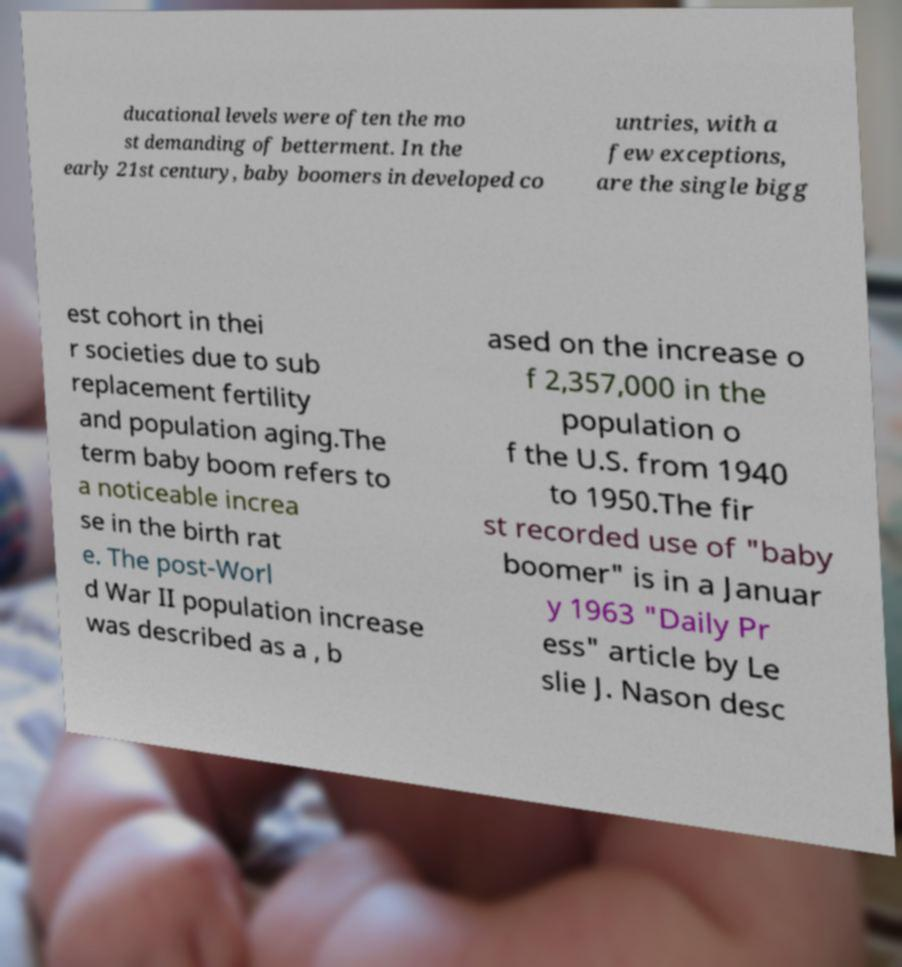For documentation purposes, I need the text within this image transcribed. Could you provide that? ducational levels were often the mo st demanding of betterment. In the early 21st century, baby boomers in developed co untries, with a few exceptions, are the single bigg est cohort in thei r societies due to sub replacement fertility and population aging.The term baby boom refers to a noticeable increa se in the birth rat e. The post-Worl d War II population increase was described as a , b ased on the increase o f 2,357,000 in the population o f the U.S. from 1940 to 1950.The fir st recorded use of "baby boomer" is in a Januar y 1963 "Daily Pr ess" article by Le slie J. Nason desc 